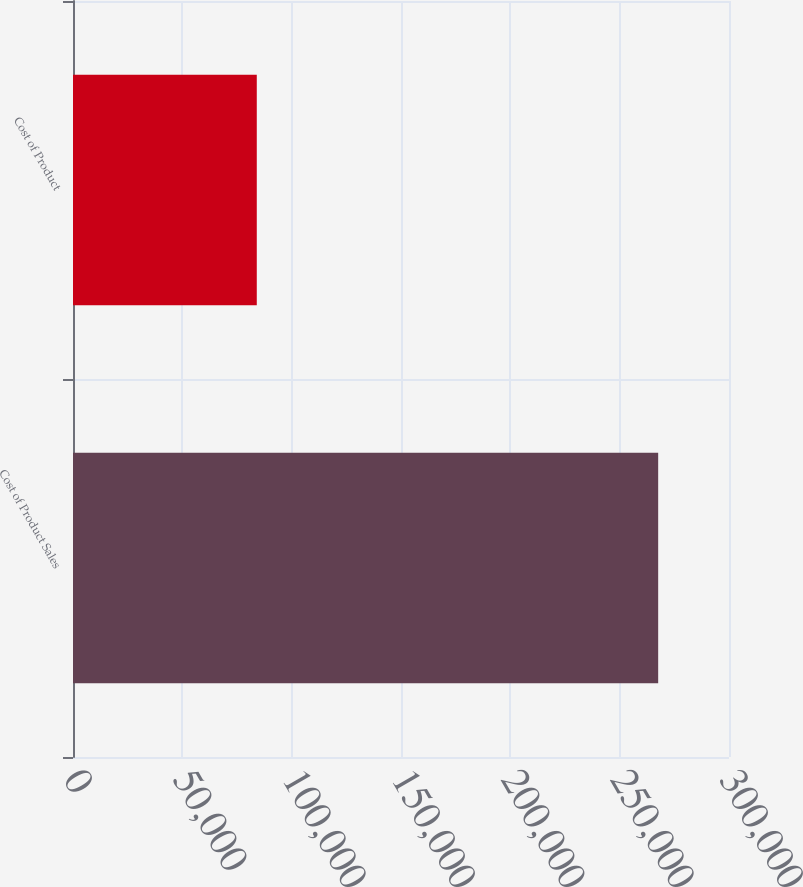Convert chart to OTSL. <chart><loc_0><loc_0><loc_500><loc_500><bar_chart><fcel>Cost of Product Sales<fcel>Cost of Product<nl><fcel>267612<fcel>84048<nl></chart> 